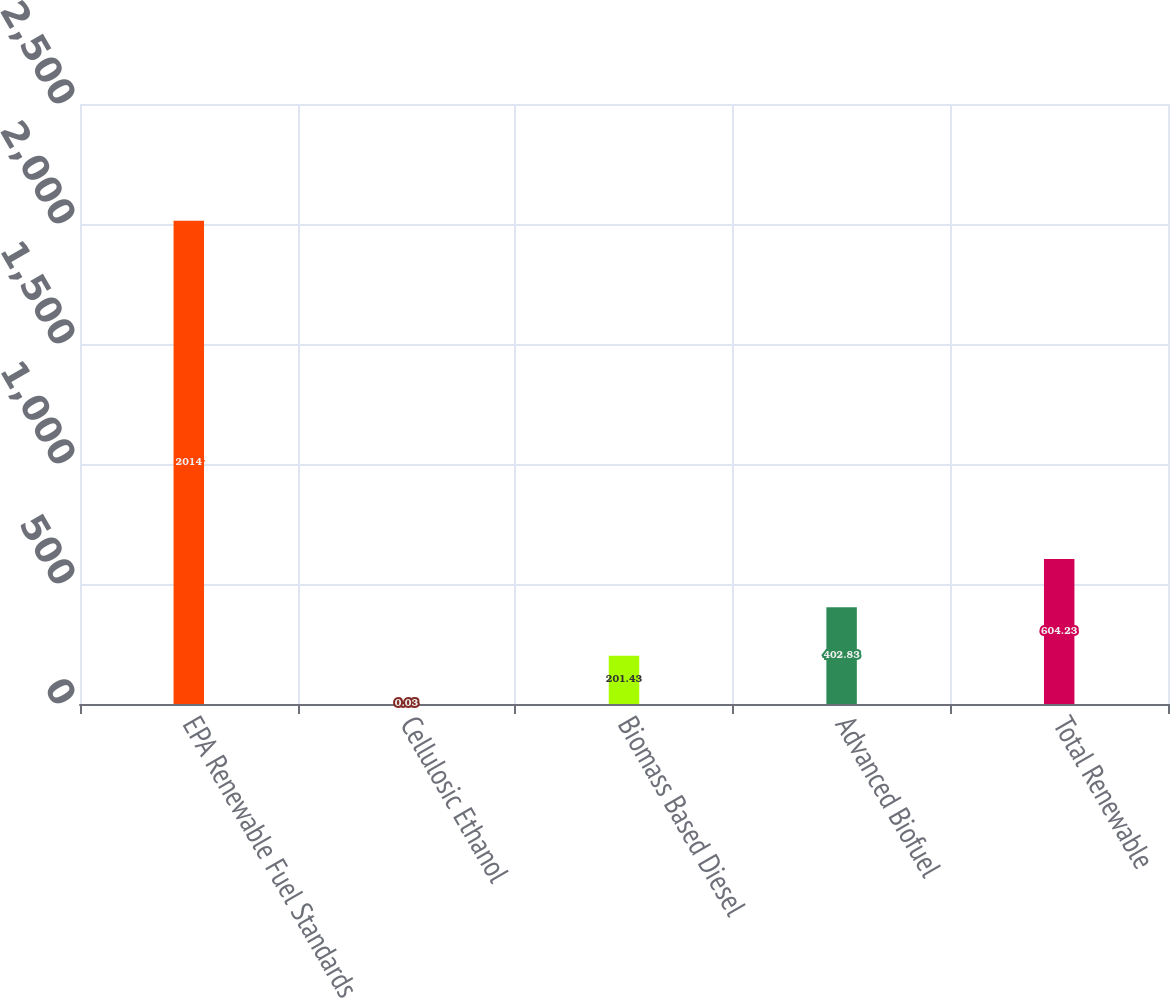Convert chart to OTSL. <chart><loc_0><loc_0><loc_500><loc_500><bar_chart><fcel>EPA Renewable Fuel Standards<fcel>Cellulosic Ethanol<fcel>Biomass Based Diesel<fcel>Advanced Biofuel<fcel>Total Renewable<nl><fcel>2014<fcel>0.03<fcel>201.43<fcel>402.83<fcel>604.23<nl></chart> 